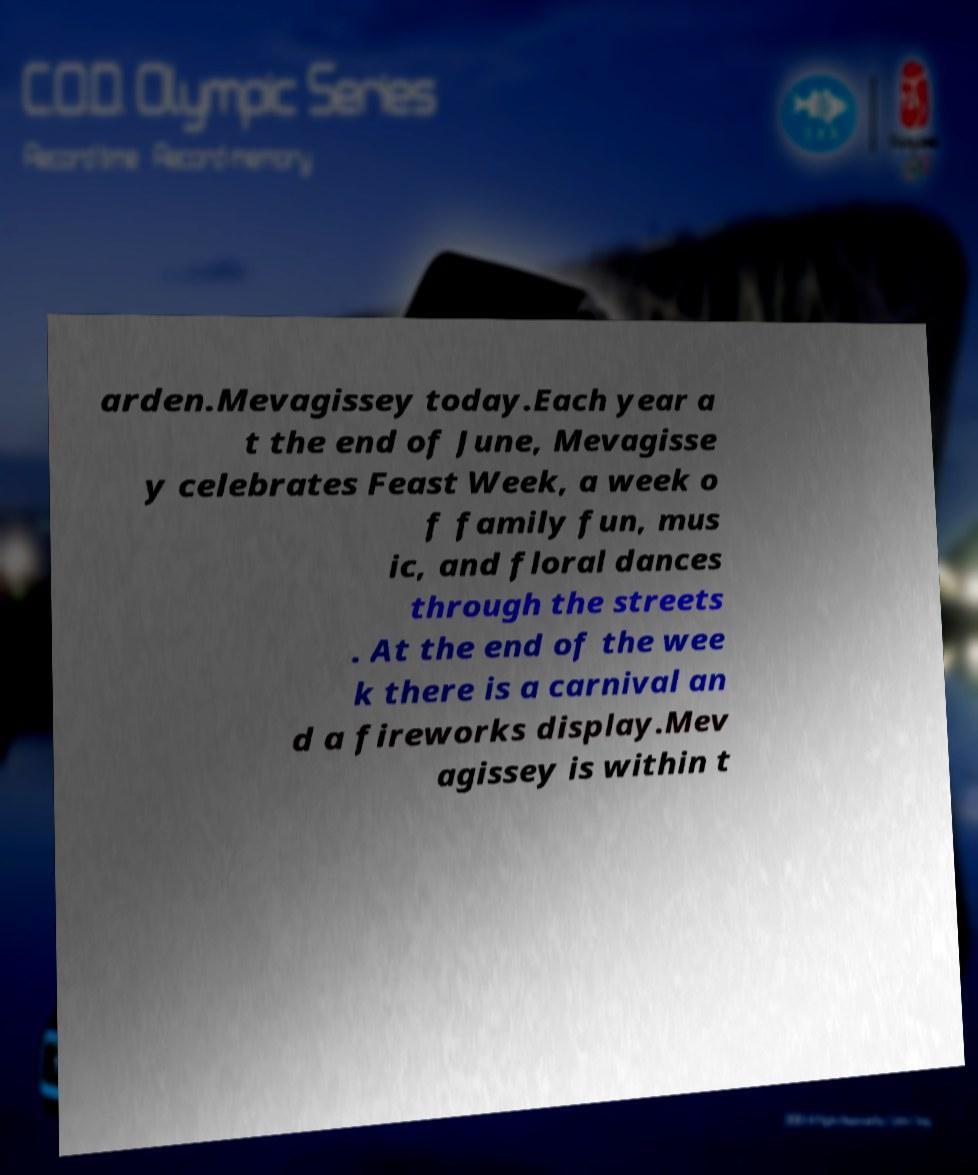There's text embedded in this image that I need extracted. Can you transcribe it verbatim? arden.Mevagissey today.Each year a t the end of June, Mevagisse y celebrates Feast Week, a week o f family fun, mus ic, and floral dances through the streets . At the end of the wee k there is a carnival an d a fireworks display.Mev agissey is within t 